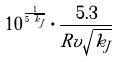Convert formula to latex. <formula><loc_0><loc_0><loc_500><loc_500>1 0 ^ { \frac { 1 } { 5 \sqrt { k _ { J } } } } \cdot \frac { 5 . 3 } { R v \sqrt { k _ { J } } }</formula> 